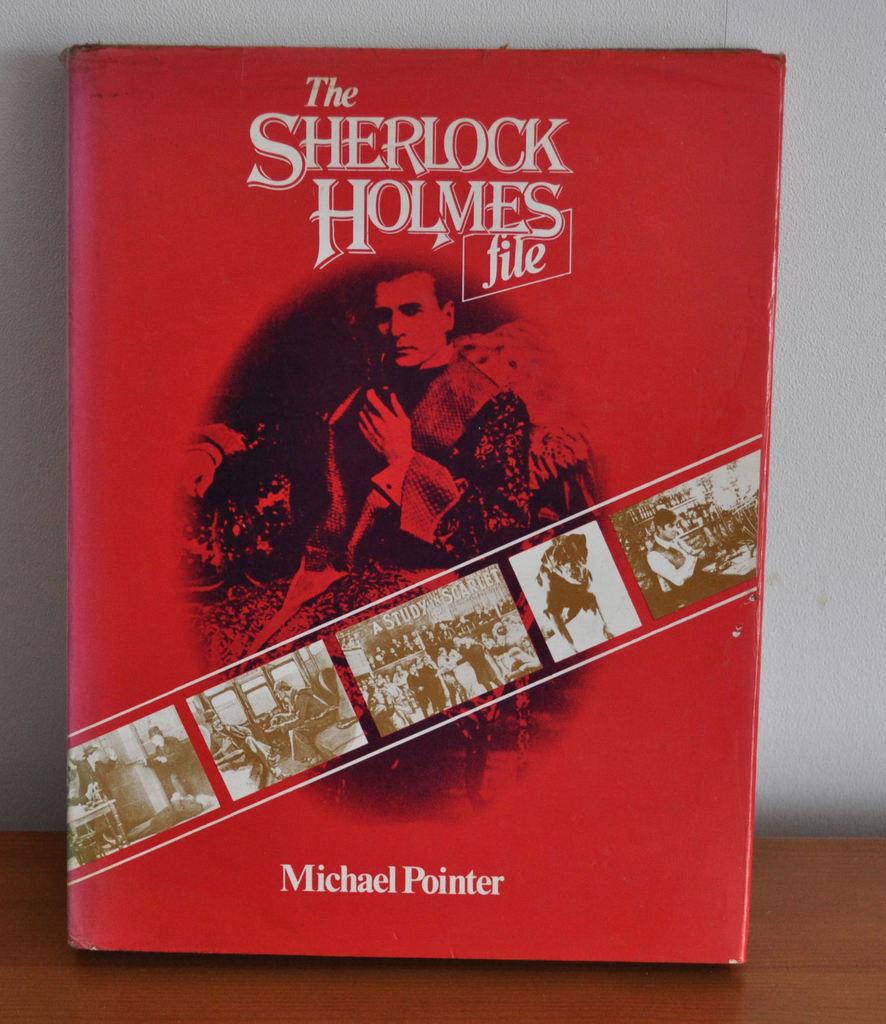What is the title of this book?
Your answer should be very brief. The sherlock holmes file. 